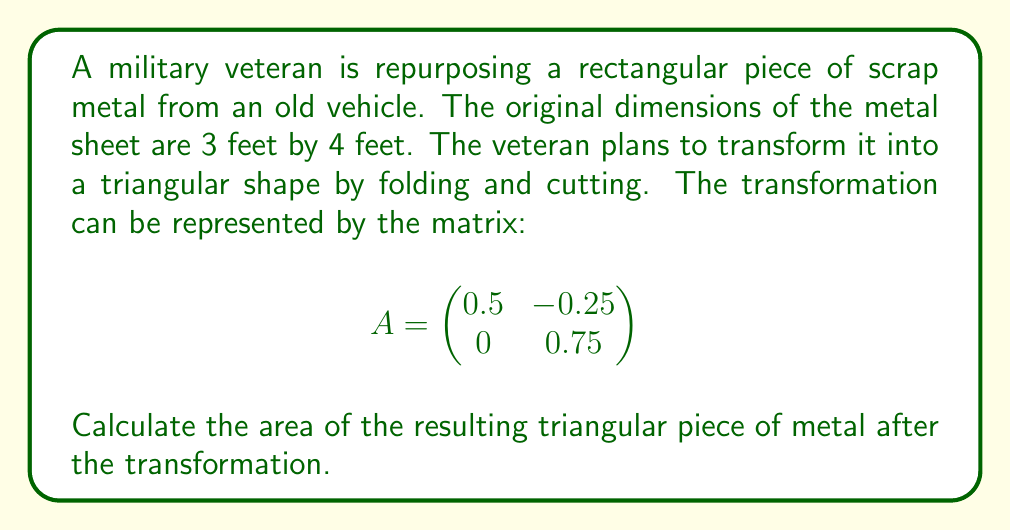Solve this math problem. Let's approach this step-by-step:

1) First, we need to represent the original rectangle as a matrix. We can do this by considering its corners as vectors:

   $$R = \begin{pmatrix}
   0 & 3 & 3 & 0 \\
   0 & 0 & 4 & 4
   \end{pmatrix}$$

2) To transform this shape, we multiply our transformation matrix A by R:

   $$AR = \begin{pmatrix}
   0.5 & -0.25 \\
   0 & 0.75
   \end{pmatrix} \begin{pmatrix}
   0 & 3 & 3 & 0 \\
   0 & 0 & 4 & 4
   \end{pmatrix}$$

3) Performing the matrix multiplication:

   $$AR = \begin{pmatrix}
   0 & 1.5 & 0.5 & -1 \\
   0 & 0 & 3 & 3
   \end{pmatrix}$$

4) This new matrix represents the coordinates of the transformed shape. We can see that it forms a triangle with vertices at (0,0), (1.5,0), and (0.5,3).

5) To find the area of this triangle, we can use the formula:
   Area = $\frac{1}{2}|x_1(y_2 - y_3) + x_2(y_3 - y_1) + x_3(y_1 - y_2)|$

   Where $(x_1,y_1)$, $(x_2,y_2)$, and $(x_3,y_3)$ are the coordinates of the three vertices.

6) Plugging in our values:
   Area = $\frac{1}{2}|0(0 - 3) + 1.5(3 - 0) + 0.5(0 - 0)|$
        = $\frac{1}{2}|0 + 4.5 + 0|$
        = $\frac{1}{2}(4.5)$
        = 2.25

Therefore, the area of the resulting triangular piece of metal is 2.25 square feet.
Answer: 2.25 sq ft 